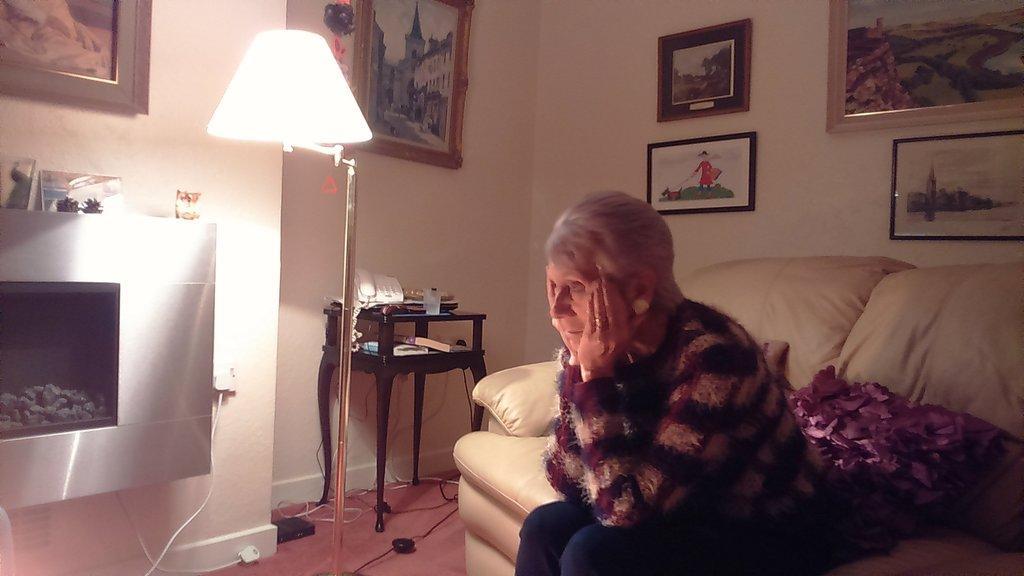Please provide a concise description of this image. This woman is sitting on a couch. On a couch there are pillows. Different type of photos on wall. This is a lantern lamp with stand. On this table there is a telephone, books and bottle. On floor there are cables. 